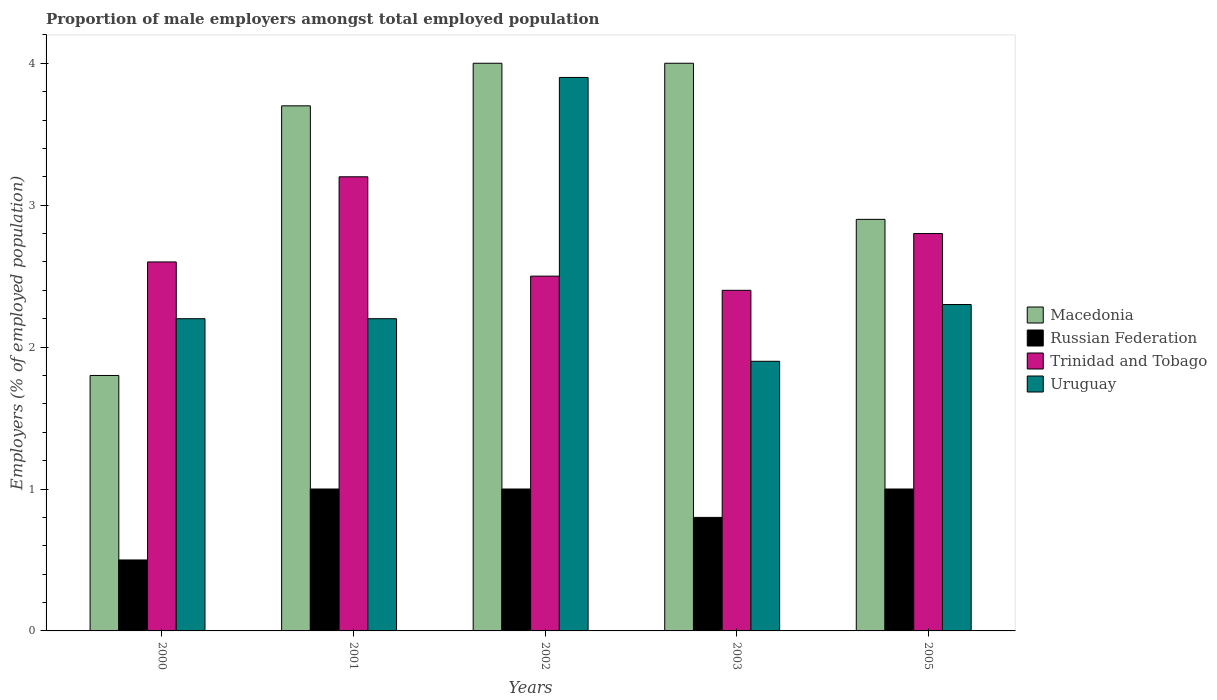How many groups of bars are there?
Your answer should be very brief. 5. What is the label of the 2nd group of bars from the left?
Give a very brief answer. 2001. In how many cases, is the number of bars for a given year not equal to the number of legend labels?
Ensure brevity in your answer.  0. What is the proportion of male employers in Uruguay in 2003?
Ensure brevity in your answer.  1.9. Across all years, what is the maximum proportion of male employers in Russian Federation?
Offer a very short reply. 1. Across all years, what is the minimum proportion of male employers in Trinidad and Tobago?
Keep it short and to the point. 2.4. In which year was the proportion of male employers in Russian Federation minimum?
Your answer should be very brief. 2000. What is the total proportion of male employers in Uruguay in the graph?
Your answer should be very brief. 12.5. What is the difference between the proportion of male employers in Trinidad and Tobago in 2002 and that in 2003?
Provide a short and direct response. 0.1. What is the difference between the proportion of male employers in Trinidad and Tobago in 2000 and the proportion of male employers in Macedonia in 2001?
Offer a very short reply. -1.1. What is the average proportion of male employers in Russian Federation per year?
Offer a very short reply. 0.86. In the year 2000, what is the difference between the proportion of male employers in Macedonia and proportion of male employers in Russian Federation?
Keep it short and to the point. 1.3. In how many years, is the proportion of male employers in Russian Federation greater than 3.2 %?
Provide a short and direct response. 0. What is the ratio of the proportion of male employers in Macedonia in 2000 to that in 2002?
Make the answer very short. 0.45. In how many years, is the proportion of male employers in Russian Federation greater than the average proportion of male employers in Russian Federation taken over all years?
Give a very brief answer. 3. Is the sum of the proportion of male employers in Macedonia in 2003 and 2005 greater than the maximum proportion of male employers in Russian Federation across all years?
Provide a succinct answer. Yes. Is it the case that in every year, the sum of the proportion of male employers in Macedonia and proportion of male employers in Russian Federation is greater than the sum of proportion of male employers in Trinidad and Tobago and proportion of male employers in Uruguay?
Provide a short and direct response. Yes. What does the 3rd bar from the left in 2003 represents?
Provide a short and direct response. Trinidad and Tobago. What does the 4th bar from the right in 2000 represents?
Your answer should be very brief. Macedonia. How many bars are there?
Your response must be concise. 20. Are all the bars in the graph horizontal?
Ensure brevity in your answer.  No. How many years are there in the graph?
Provide a succinct answer. 5. What is the difference between two consecutive major ticks on the Y-axis?
Provide a succinct answer. 1. Are the values on the major ticks of Y-axis written in scientific E-notation?
Provide a succinct answer. No. Does the graph contain any zero values?
Your answer should be compact. No. Does the graph contain grids?
Your answer should be very brief. No. What is the title of the graph?
Your answer should be compact. Proportion of male employers amongst total employed population. What is the label or title of the Y-axis?
Offer a very short reply. Employers (% of employed population). What is the Employers (% of employed population) of Macedonia in 2000?
Offer a very short reply. 1.8. What is the Employers (% of employed population) in Russian Federation in 2000?
Your answer should be compact. 0.5. What is the Employers (% of employed population) in Trinidad and Tobago in 2000?
Keep it short and to the point. 2.6. What is the Employers (% of employed population) of Uruguay in 2000?
Provide a short and direct response. 2.2. What is the Employers (% of employed population) in Macedonia in 2001?
Keep it short and to the point. 3.7. What is the Employers (% of employed population) of Trinidad and Tobago in 2001?
Keep it short and to the point. 3.2. What is the Employers (% of employed population) of Uruguay in 2001?
Your answer should be compact. 2.2. What is the Employers (% of employed population) in Macedonia in 2002?
Your answer should be very brief. 4. What is the Employers (% of employed population) of Uruguay in 2002?
Your answer should be very brief. 3.9. What is the Employers (% of employed population) in Russian Federation in 2003?
Offer a terse response. 0.8. What is the Employers (% of employed population) in Trinidad and Tobago in 2003?
Make the answer very short. 2.4. What is the Employers (% of employed population) of Uruguay in 2003?
Make the answer very short. 1.9. What is the Employers (% of employed population) of Macedonia in 2005?
Provide a succinct answer. 2.9. What is the Employers (% of employed population) in Russian Federation in 2005?
Make the answer very short. 1. What is the Employers (% of employed population) in Trinidad and Tobago in 2005?
Keep it short and to the point. 2.8. What is the Employers (% of employed population) in Uruguay in 2005?
Offer a very short reply. 2.3. Across all years, what is the maximum Employers (% of employed population) in Macedonia?
Provide a short and direct response. 4. Across all years, what is the maximum Employers (% of employed population) in Trinidad and Tobago?
Provide a short and direct response. 3.2. Across all years, what is the maximum Employers (% of employed population) in Uruguay?
Keep it short and to the point. 3.9. Across all years, what is the minimum Employers (% of employed population) of Macedonia?
Your answer should be compact. 1.8. Across all years, what is the minimum Employers (% of employed population) in Trinidad and Tobago?
Offer a terse response. 2.4. Across all years, what is the minimum Employers (% of employed population) in Uruguay?
Offer a very short reply. 1.9. What is the total Employers (% of employed population) in Trinidad and Tobago in the graph?
Offer a very short reply. 13.5. What is the total Employers (% of employed population) in Uruguay in the graph?
Offer a very short reply. 12.5. What is the difference between the Employers (% of employed population) in Trinidad and Tobago in 2000 and that in 2002?
Offer a very short reply. 0.1. What is the difference between the Employers (% of employed population) of Uruguay in 2000 and that in 2003?
Give a very brief answer. 0.3. What is the difference between the Employers (% of employed population) in Uruguay in 2001 and that in 2002?
Your answer should be compact. -1.7. What is the difference between the Employers (% of employed population) in Russian Federation in 2001 and that in 2003?
Provide a succinct answer. 0.2. What is the difference between the Employers (% of employed population) in Uruguay in 2001 and that in 2003?
Your answer should be very brief. 0.3. What is the difference between the Employers (% of employed population) of Macedonia in 2001 and that in 2005?
Keep it short and to the point. 0.8. What is the difference between the Employers (% of employed population) of Uruguay in 2001 and that in 2005?
Your response must be concise. -0.1. What is the difference between the Employers (% of employed population) in Russian Federation in 2002 and that in 2003?
Your answer should be very brief. 0.2. What is the difference between the Employers (% of employed population) in Trinidad and Tobago in 2002 and that in 2003?
Offer a very short reply. 0.1. What is the difference between the Employers (% of employed population) of Russian Federation in 2002 and that in 2005?
Provide a succinct answer. 0. What is the difference between the Employers (% of employed population) of Trinidad and Tobago in 2002 and that in 2005?
Your answer should be very brief. -0.3. What is the difference between the Employers (% of employed population) in Macedonia in 2003 and that in 2005?
Your answer should be very brief. 1.1. What is the difference between the Employers (% of employed population) of Russian Federation in 2003 and that in 2005?
Your answer should be very brief. -0.2. What is the difference between the Employers (% of employed population) of Macedonia in 2000 and the Employers (% of employed population) of Russian Federation in 2001?
Give a very brief answer. 0.8. What is the difference between the Employers (% of employed population) of Macedonia in 2000 and the Employers (% of employed population) of Trinidad and Tobago in 2001?
Provide a short and direct response. -1.4. What is the difference between the Employers (% of employed population) of Macedonia in 2000 and the Employers (% of employed population) of Uruguay in 2001?
Your answer should be compact. -0.4. What is the difference between the Employers (% of employed population) of Macedonia in 2000 and the Employers (% of employed population) of Trinidad and Tobago in 2002?
Ensure brevity in your answer.  -0.7. What is the difference between the Employers (% of employed population) in Macedonia in 2000 and the Employers (% of employed population) in Uruguay in 2002?
Make the answer very short. -2.1. What is the difference between the Employers (% of employed population) in Russian Federation in 2000 and the Employers (% of employed population) in Trinidad and Tobago in 2002?
Provide a succinct answer. -2. What is the difference between the Employers (% of employed population) of Russian Federation in 2000 and the Employers (% of employed population) of Uruguay in 2002?
Provide a succinct answer. -3.4. What is the difference between the Employers (% of employed population) in Trinidad and Tobago in 2000 and the Employers (% of employed population) in Uruguay in 2002?
Offer a terse response. -1.3. What is the difference between the Employers (% of employed population) in Russian Federation in 2000 and the Employers (% of employed population) in Trinidad and Tobago in 2003?
Provide a short and direct response. -1.9. What is the difference between the Employers (% of employed population) in Trinidad and Tobago in 2000 and the Employers (% of employed population) in Uruguay in 2003?
Your answer should be compact. 0.7. What is the difference between the Employers (% of employed population) of Macedonia in 2000 and the Employers (% of employed population) of Trinidad and Tobago in 2005?
Offer a very short reply. -1. What is the difference between the Employers (% of employed population) of Macedonia in 2000 and the Employers (% of employed population) of Uruguay in 2005?
Give a very brief answer. -0.5. What is the difference between the Employers (% of employed population) in Russian Federation in 2000 and the Employers (% of employed population) in Trinidad and Tobago in 2005?
Ensure brevity in your answer.  -2.3. What is the difference between the Employers (% of employed population) in Russian Federation in 2000 and the Employers (% of employed population) in Uruguay in 2005?
Your response must be concise. -1.8. What is the difference between the Employers (% of employed population) of Trinidad and Tobago in 2000 and the Employers (% of employed population) of Uruguay in 2005?
Provide a succinct answer. 0.3. What is the difference between the Employers (% of employed population) in Macedonia in 2001 and the Employers (% of employed population) in Trinidad and Tobago in 2002?
Make the answer very short. 1.2. What is the difference between the Employers (% of employed population) of Macedonia in 2001 and the Employers (% of employed population) of Uruguay in 2002?
Your answer should be very brief. -0.2. What is the difference between the Employers (% of employed population) in Russian Federation in 2001 and the Employers (% of employed population) in Trinidad and Tobago in 2002?
Your answer should be compact. -1.5. What is the difference between the Employers (% of employed population) of Macedonia in 2001 and the Employers (% of employed population) of Trinidad and Tobago in 2003?
Keep it short and to the point. 1.3. What is the difference between the Employers (% of employed population) of Macedonia in 2001 and the Employers (% of employed population) of Uruguay in 2003?
Offer a very short reply. 1.8. What is the difference between the Employers (% of employed population) in Russian Federation in 2001 and the Employers (% of employed population) in Uruguay in 2003?
Provide a short and direct response. -0.9. What is the difference between the Employers (% of employed population) of Russian Federation in 2001 and the Employers (% of employed population) of Uruguay in 2005?
Give a very brief answer. -1.3. What is the difference between the Employers (% of employed population) in Macedonia in 2002 and the Employers (% of employed population) in Russian Federation in 2003?
Provide a short and direct response. 3.2. What is the difference between the Employers (% of employed population) of Macedonia in 2002 and the Employers (% of employed population) of Uruguay in 2003?
Provide a short and direct response. 2.1. What is the difference between the Employers (% of employed population) in Trinidad and Tobago in 2002 and the Employers (% of employed population) in Uruguay in 2003?
Provide a succinct answer. 0.6. What is the difference between the Employers (% of employed population) in Macedonia in 2002 and the Employers (% of employed population) in Uruguay in 2005?
Your response must be concise. 1.7. What is the difference between the Employers (% of employed population) in Russian Federation in 2002 and the Employers (% of employed population) in Trinidad and Tobago in 2005?
Give a very brief answer. -1.8. What is the difference between the Employers (% of employed population) in Macedonia in 2003 and the Employers (% of employed population) in Uruguay in 2005?
Give a very brief answer. 1.7. What is the difference between the Employers (% of employed population) of Russian Federation in 2003 and the Employers (% of employed population) of Trinidad and Tobago in 2005?
Provide a short and direct response. -2. What is the difference between the Employers (% of employed population) in Trinidad and Tobago in 2003 and the Employers (% of employed population) in Uruguay in 2005?
Ensure brevity in your answer.  0.1. What is the average Employers (% of employed population) in Macedonia per year?
Your response must be concise. 3.28. What is the average Employers (% of employed population) in Russian Federation per year?
Provide a short and direct response. 0.86. What is the average Employers (% of employed population) of Trinidad and Tobago per year?
Your response must be concise. 2.7. In the year 2000, what is the difference between the Employers (% of employed population) in Macedonia and Employers (% of employed population) in Trinidad and Tobago?
Ensure brevity in your answer.  -0.8. In the year 2000, what is the difference between the Employers (% of employed population) in Russian Federation and Employers (% of employed population) in Trinidad and Tobago?
Offer a terse response. -2.1. In the year 2001, what is the difference between the Employers (% of employed population) in Macedonia and Employers (% of employed population) in Russian Federation?
Your answer should be compact. 2.7. In the year 2001, what is the difference between the Employers (% of employed population) of Trinidad and Tobago and Employers (% of employed population) of Uruguay?
Keep it short and to the point. 1. In the year 2002, what is the difference between the Employers (% of employed population) in Russian Federation and Employers (% of employed population) in Uruguay?
Your answer should be very brief. -2.9. In the year 2002, what is the difference between the Employers (% of employed population) of Trinidad and Tobago and Employers (% of employed population) of Uruguay?
Your answer should be very brief. -1.4. In the year 2003, what is the difference between the Employers (% of employed population) of Macedonia and Employers (% of employed population) of Trinidad and Tobago?
Provide a short and direct response. 1.6. In the year 2003, what is the difference between the Employers (% of employed population) in Macedonia and Employers (% of employed population) in Uruguay?
Keep it short and to the point. 2.1. In the year 2003, what is the difference between the Employers (% of employed population) of Russian Federation and Employers (% of employed population) of Trinidad and Tobago?
Your answer should be compact. -1.6. In the year 2003, what is the difference between the Employers (% of employed population) in Trinidad and Tobago and Employers (% of employed population) in Uruguay?
Offer a terse response. 0.5. In the year 2005, what is the difference between the Employers (% of employed population) of Macedonia and Employers (% of employed population) of Russian Federation?
Provide a short and direct response. 1.9. In the year 2005, what is the difference between the Employers (% of employed population) in Macedonia and Employers (% of employed population) in Trinidad and Tobago?
Your response must be concise. 0.1. In the year 2005, what is the difference between the Employers (% of employed population) of Russian Federation and Employers (% of employed population) of Uruguay?
Your response must be concise. -1.3. In the year 2005, what is the difference between the Employers (% of employed population) in Trinidad and Tobago and Employers (% of employed population) in Uruguay?
Offer a terse response. 0.5. What is the ratio of the Employers (% of employed population) in Macedonia in 2000 to that in 2001?
Make the answer very short. 0.49. What is the ratio of the Employers (% of employed population) of Trinidad and Tobago in 2000 to that in 2001?
Provide a short and direct response. 0.81. What is the ratio of the Employers (% of employed population) of Uruguay in 2000 to that in 2001?
Provide a short and direct response. 1. What is the ratio of the Employers (% of employed population) of Macedonia in 2000 to that in 2002?
Ensure brevity in your answer.  0.45. What is the ratio of the Employers (% of employed population) in Russian Federation in 2000 to that in 2002?
Provide a succinct answer. 0.5. What is the ratio of the Employers (% of employed population) of Uruguay in 2000 to that in 2002?
Give a very brief answer. 0.56. What is the ratio of the Employers (% of employed population) in Macedonia in 2000 to that in 2003?
Your answer should be compact. 0.45. What is the ratio of the Employers (% of employed population) in Russian Federation in 2000 to that in 2003?
Give a very brief answer. 0.62. What is the ratio of the Employers (% of employed population) in Uruguay in 2000 to that in 2003?
Offer a very short reply. 1.16. What is the ratio of the Employers (% of employed population) of Macedonia in 2000 to that in 2005?
Your answer should be very brief. 0.62. What is the ratio of the Employers (% of employed population) of Russian Federation in 2000 to that in 2005?
Offer a very short reply. 0.5. What is the ratio of the Employers (% of employed population) of Trinidad and Tobago in 2000 to that in 2005?
Give a very brief answer. 0.93. What is the ratio of the Employers (% of employed population) of Uruguay in 2000 to that in 2005?
Your response must be concise. 0.96. What is the ratio of the Employers (% of employed population) of Macedonia in 2001 to that in 2002?
Offer a terse response. 0.93. What is the ratio of the Employers (% of employed population) in Russian Federation in 2001 to that in 2002?
Your answer should be compact. 1. What is the ratio of the Employers (% of employed population) in Trinidad and Tobago in 2001 to that in 2002?
Your answer should be very brief. 1.28. What is the ratio of the Employers (% of employed population) in Uruguay in 2001 to that in 2002?
Your response must be concise. 0.56. What is the ratio of the Employers (% of employed population) in Macedonia in 2001 to that in 2003?
Provide a succinct answer. 0.93. What is the ratio of the Employers (% of employed population) in Russian Federation in 2001 to that in 2003?
Make the answer very short. 1.25. What is the ratio of the Employers (% of employed population) in Trinidad and Tobago in 2001 to that in 2003?
Make the answer very short. 1.33. What is the ratio of the Employers (% of employed population) in Uruguay in 2001 to that in 2003?
Keep it short and to the point. 1.16. What is the ratio of the Employers (% of employed population) of Macedonia in 2001 to that in 2005?
Provide a short and direct response. 1.28. What is the ratio of the Employers (% of employed population) in Russian Federation in 2001 to that in 2005?
Offer a very short reply. 1. What is the ratio of the Employers (% of employed population) of Uruguay in 2001 to that in 2005?
Offer a terse response. 0.96. What is the ratio of the Employers (% of employed population) of Macedonia in 2002 to that in 2003?
Your answer should be compact. 1. What is the ratio of the Employers (% of employed population) of Russian Federation in 2002 to that in 2003?
Your answer should be compact. 1.25. What is the ratio of the Employers (% of employed population) in Trinidad and Tobago in 2002 to that in 2003?
Your answer should be very brief. 1.04. What is the ratio of the Employers (% of employed population) in Uruguay in 2002 to that in 2003?
Keep it short and to the point. 2.05. What is the ratio of the Employers (% of employed population) in Macedonia in 2002 to that in 2005?
Offer a terse response. 1.38. What is the ratio of the Employers (% of employed population) of Russian Federation in 2002 to that in 2005?
Give a very brief answer. 1. What is the ratio of the Employers (% of employed population) in Trinidad and Tobago in 2002 to that in 2005?
Your answer should be very brief. 0.89. What is the ratio of the Employers (% of employed population) in Uruguay in 2002 to that in 2005?
Your answer should be compact. 1.7. What is the ratio of the Employers (% of employed population) of Macedonia in 2003 to that in 2005?
Ensure brevity in your answer.  1.38. What is the ratio of the Employers (% of employed population) in Russian Federation in 2003 to that in 2005?
Provide a succinct answer. 0.8. What is the ratio of the Employers (% of employed population) of Uruguay in 2003 to that in 2005?
Provide a succinct answer. 0.83. What is the difference between the highest and the second highest Employers (% of employed population) of Macedonia?
Offer a very short reply. 0. What is the difference between the highest and the second highest Employers (% of employed population) in Russian Federation?
Your answer should be compact. 0. What is the difference between the highest and the lowest Employers (% of employed population) of Macedonia?
Offer a very short reply. 2.2. 